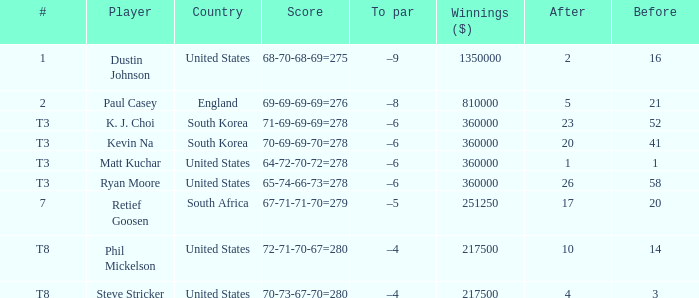What is the score when the player is Matt Kuchar? 64-72-70-72=278. 